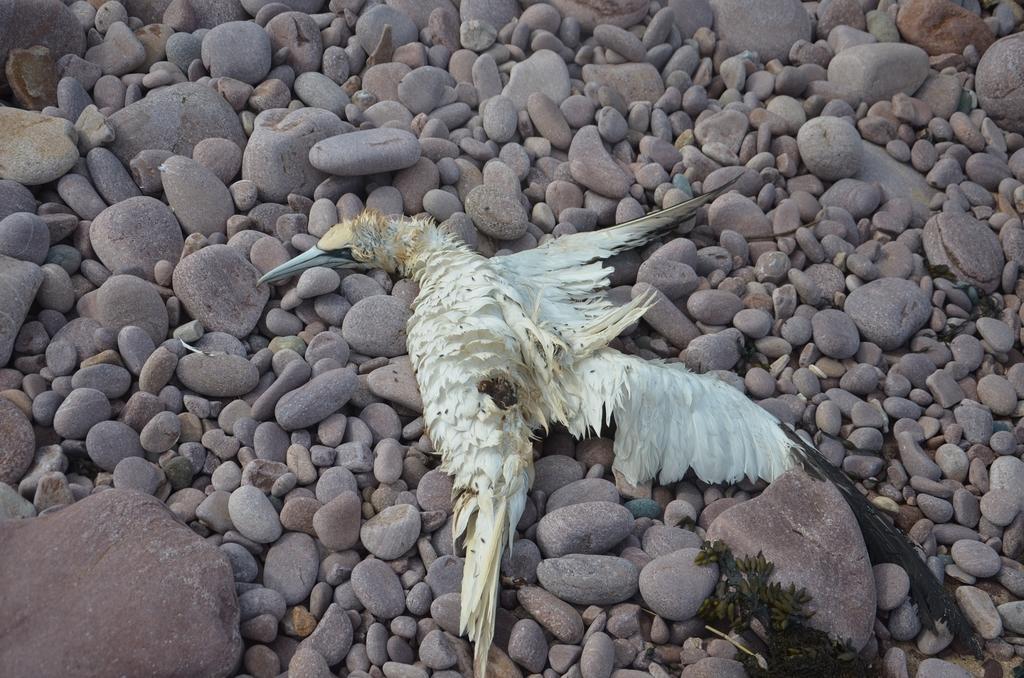Could you give a brief overview of what you see in this image? In this image we can see a bird in white color lying on the stones. 